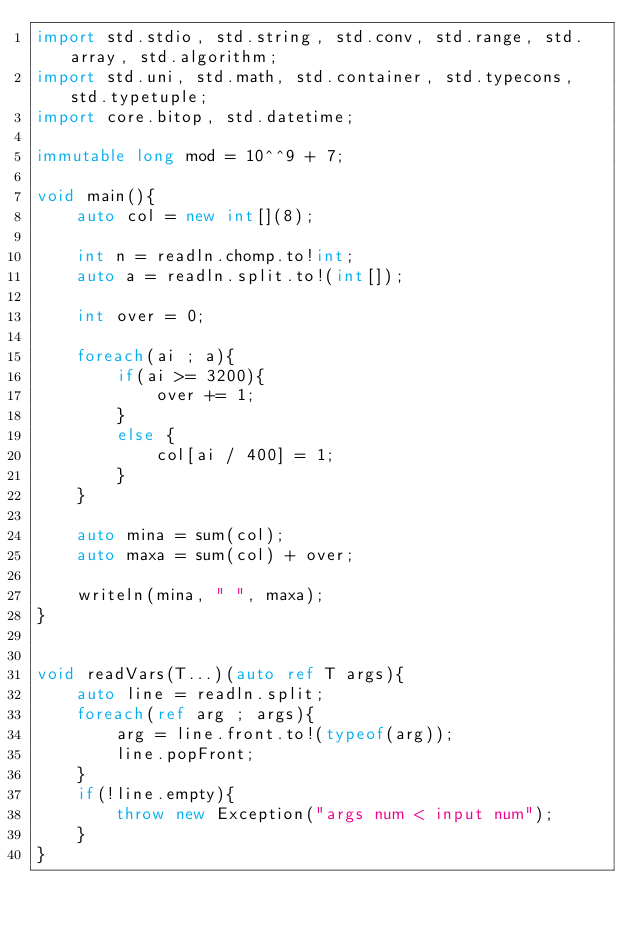Convert code to text. <code><loc_0><loc_0><loc_500><loc_500><_D_>import std.stdio, std.string, std.conv, std.range, std.array, std.algorithm;
import std.uni, std.math, std.container, std.typecons, std.typetuple;
import core.bitop, std.datetime;

immutable long mod = 10^^9 + 7;

void main(){
    auto col = new int[](8);

    int n = readln.chomp.to!int;
    auto a = readln.split.to!(int[]);

    int over = 0;

    foreach(ai ; a){
        if(ai >= 3200){
            over += 1;
        }
        else {
            col[ai / 400] = 1;
        }
    }

    auto mina = sum(col);
    auto maxa = sum(col) + over;

    writeln(mina, " ", maxa);
}


void readVars(T...)(auto ref T args){
    auto line = readln.split;
    foreach(ref arg ; args){
        arg = line.front.to!(typeof(arg));
        line.popFront;
    }
    if(!line.empty){
        throw new Exception("args num < input num");
    }
}</code> 